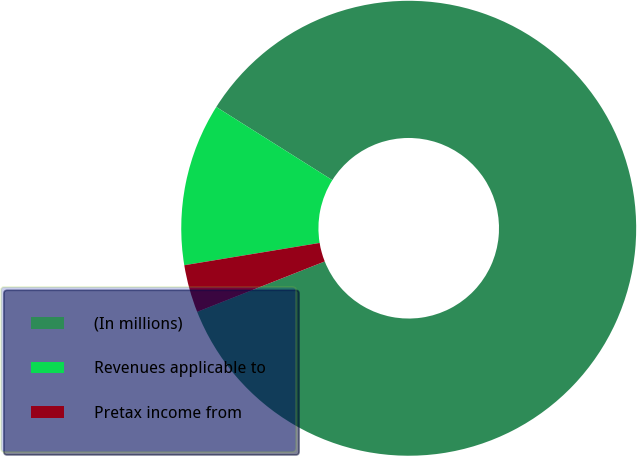<chart> <loc_0><loc_0><loc_500><loc_500><pie_chart><fcel>(In millions)<fcel>Revenues applicable to<fcel>Pretax income from<nl><fcel>85.06%<fcel>11.55%<fcel>3.39%<nl></chart> 